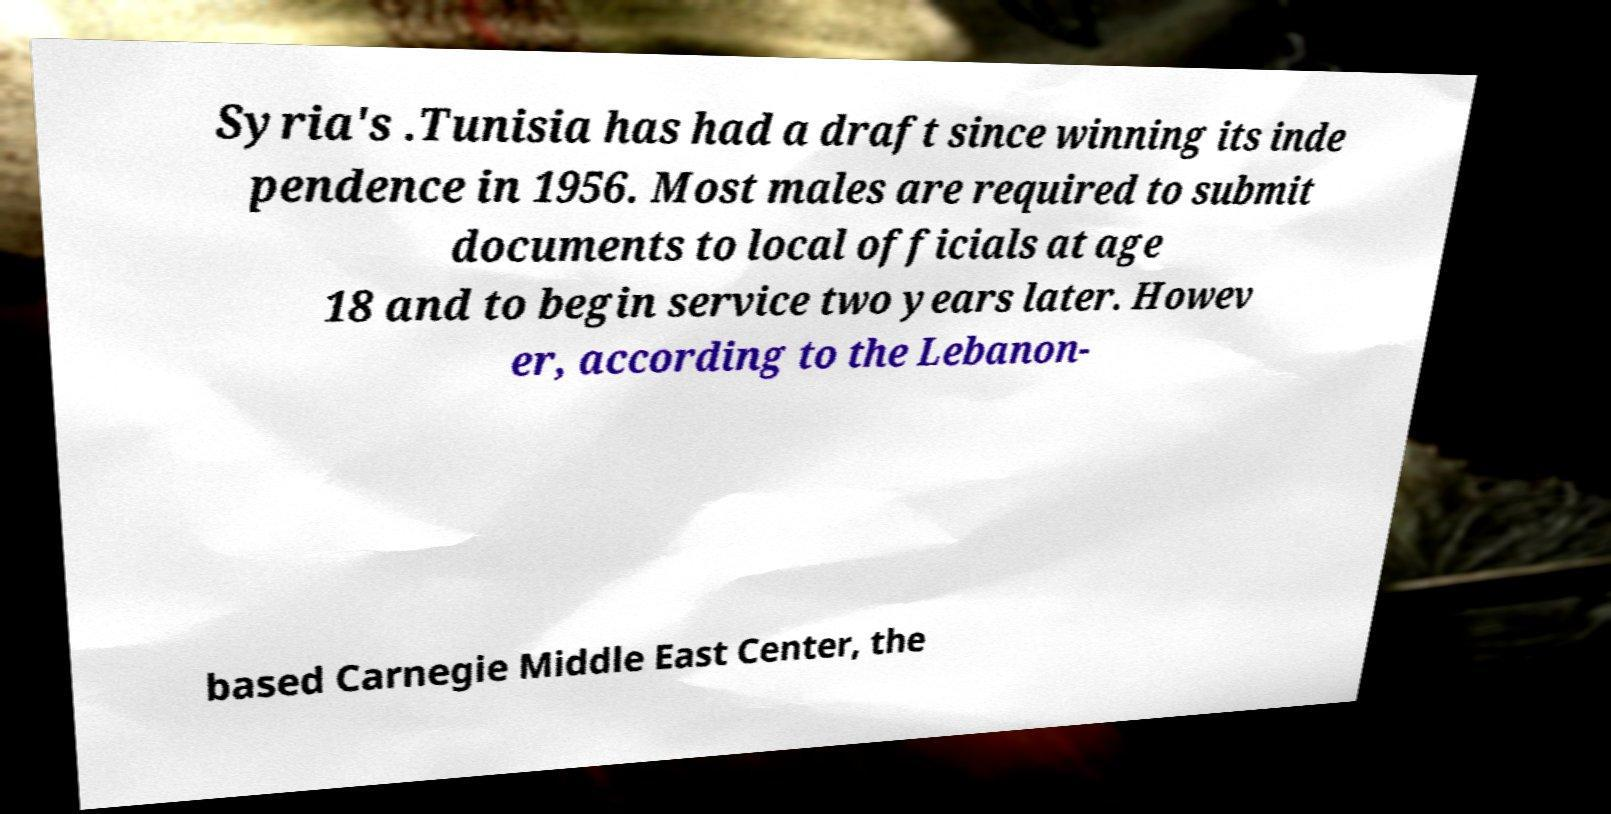There's text embedded in this image that I need extracted. Can you transcribe it verbatim? Syria's .Tunisia has had a draft since winning its inde pendence in 1956. Most males are required to submit documents to local officials at age 18 and to begin service two years later. Howev er, according to the Lebanon- based Carnegie Middle East Center, the 